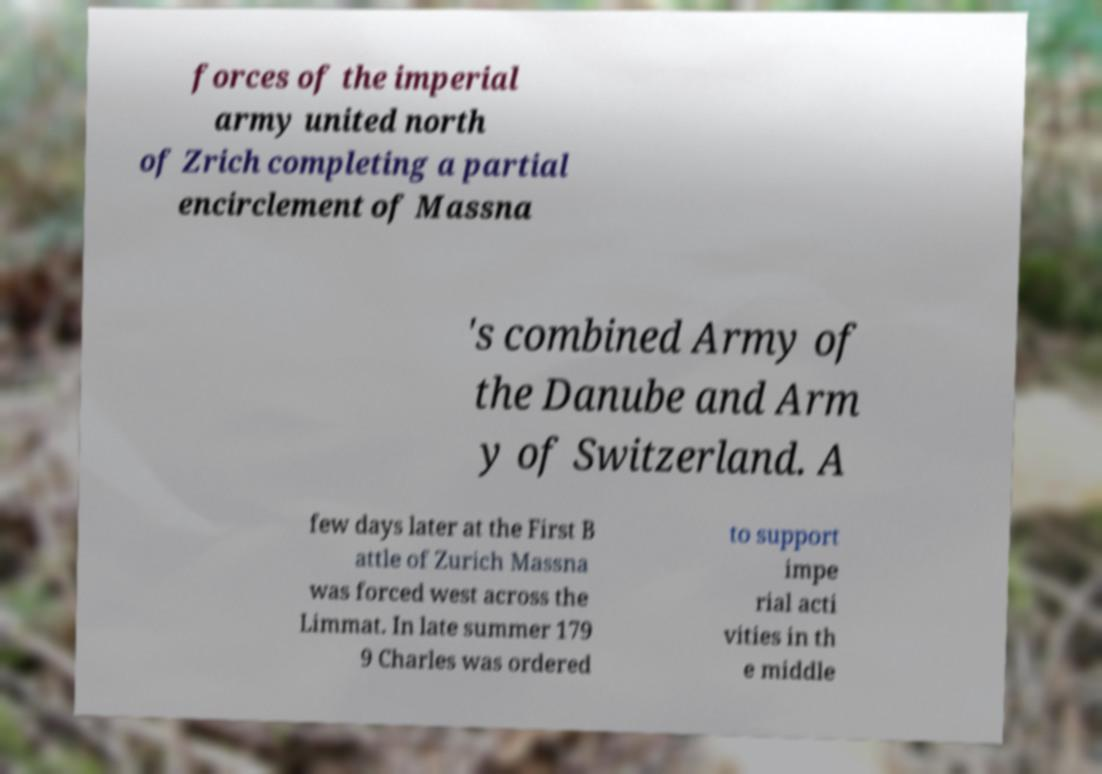Please read and relay the text visible in this image. What does it say? forces of the imperial army united north of Zrich completing a partial encirclement of Massna 's combined Army of the Danube and Arm y of Switzerland. A few days later at the First B attle of Zurich Massna was forced west across the Limmat. In late summer 179 9 Charles was ordered to support impe rial acti vities in th e middle 